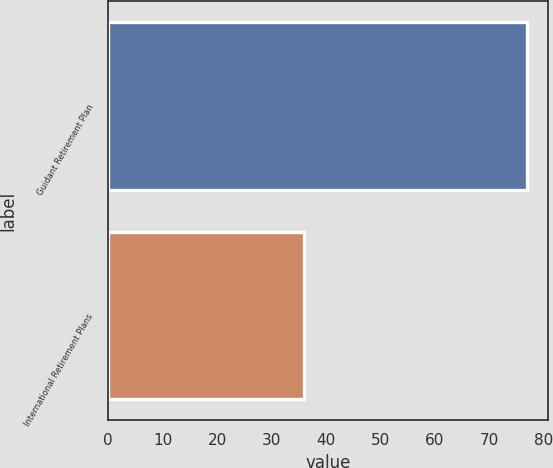Convert chart to OTSL. <chart><loc_0><loc_0><loc_500><loc_500><bar_chart><fcel>Guidant Retirement Plan<fcel>International Retirement Plans<nl><fcel>77<fcel>36<nl></chart> 